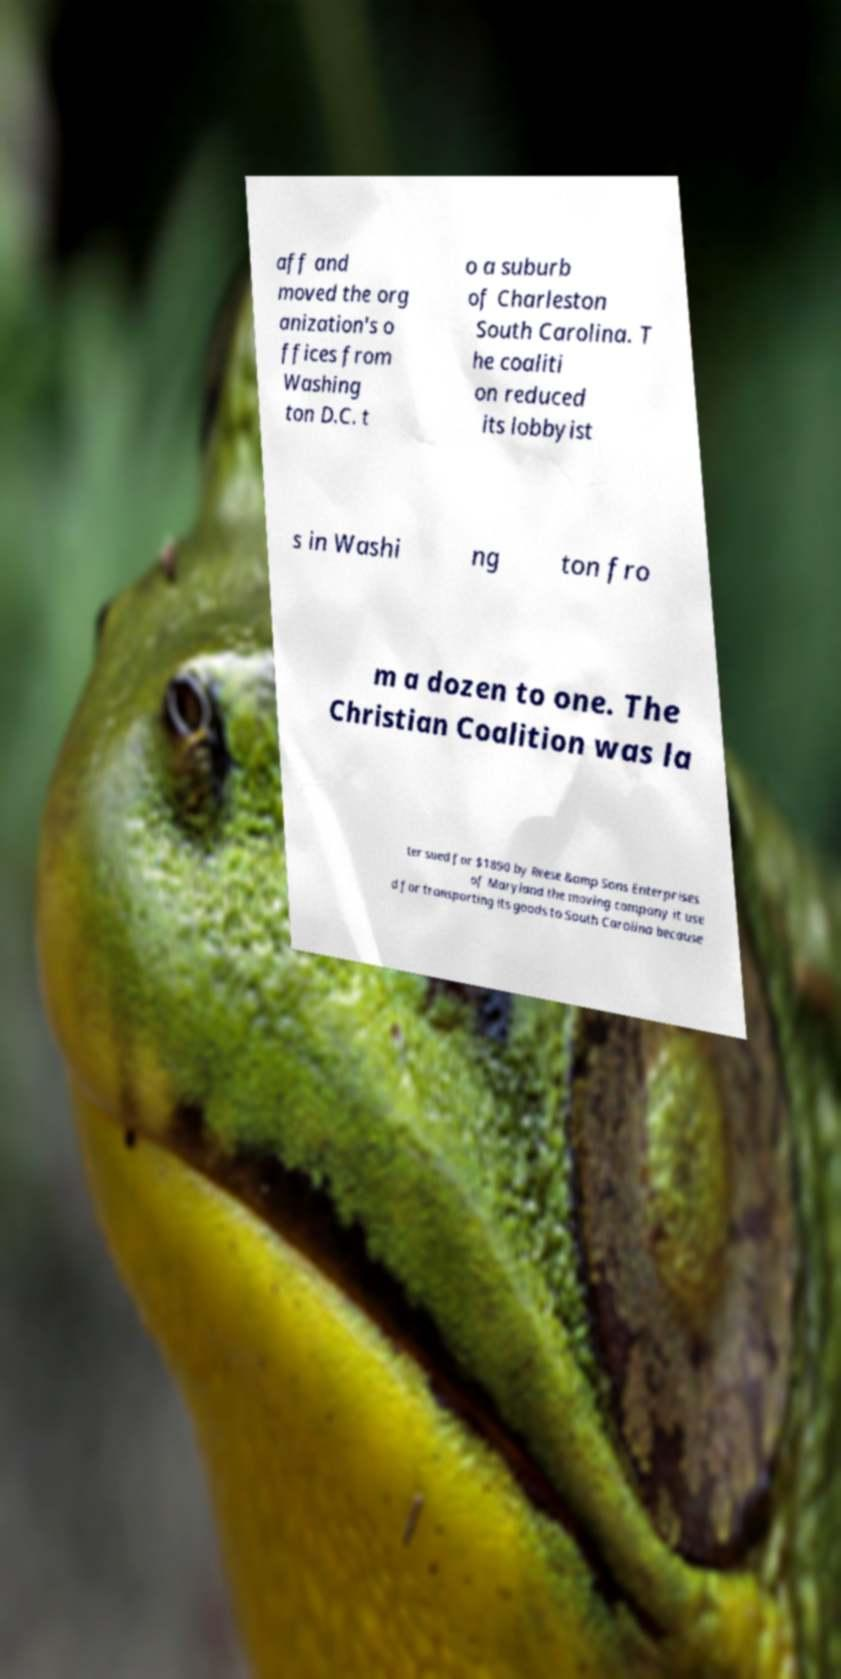Please read and relay the text visible in this image. What does it say? aff and moved the org anization's o ffices from Washing ton D.C. t o a suburb of Charleston South Carolina. T he coaliti on reduced its lobbyist s in Washi ng ton fro m a dozen to one. The Christian Coalition was la ter sued for $1890 by Reese &amp Sons Enterprises of Maryland the moving company it use d for transporting its goods to South Carolina because 